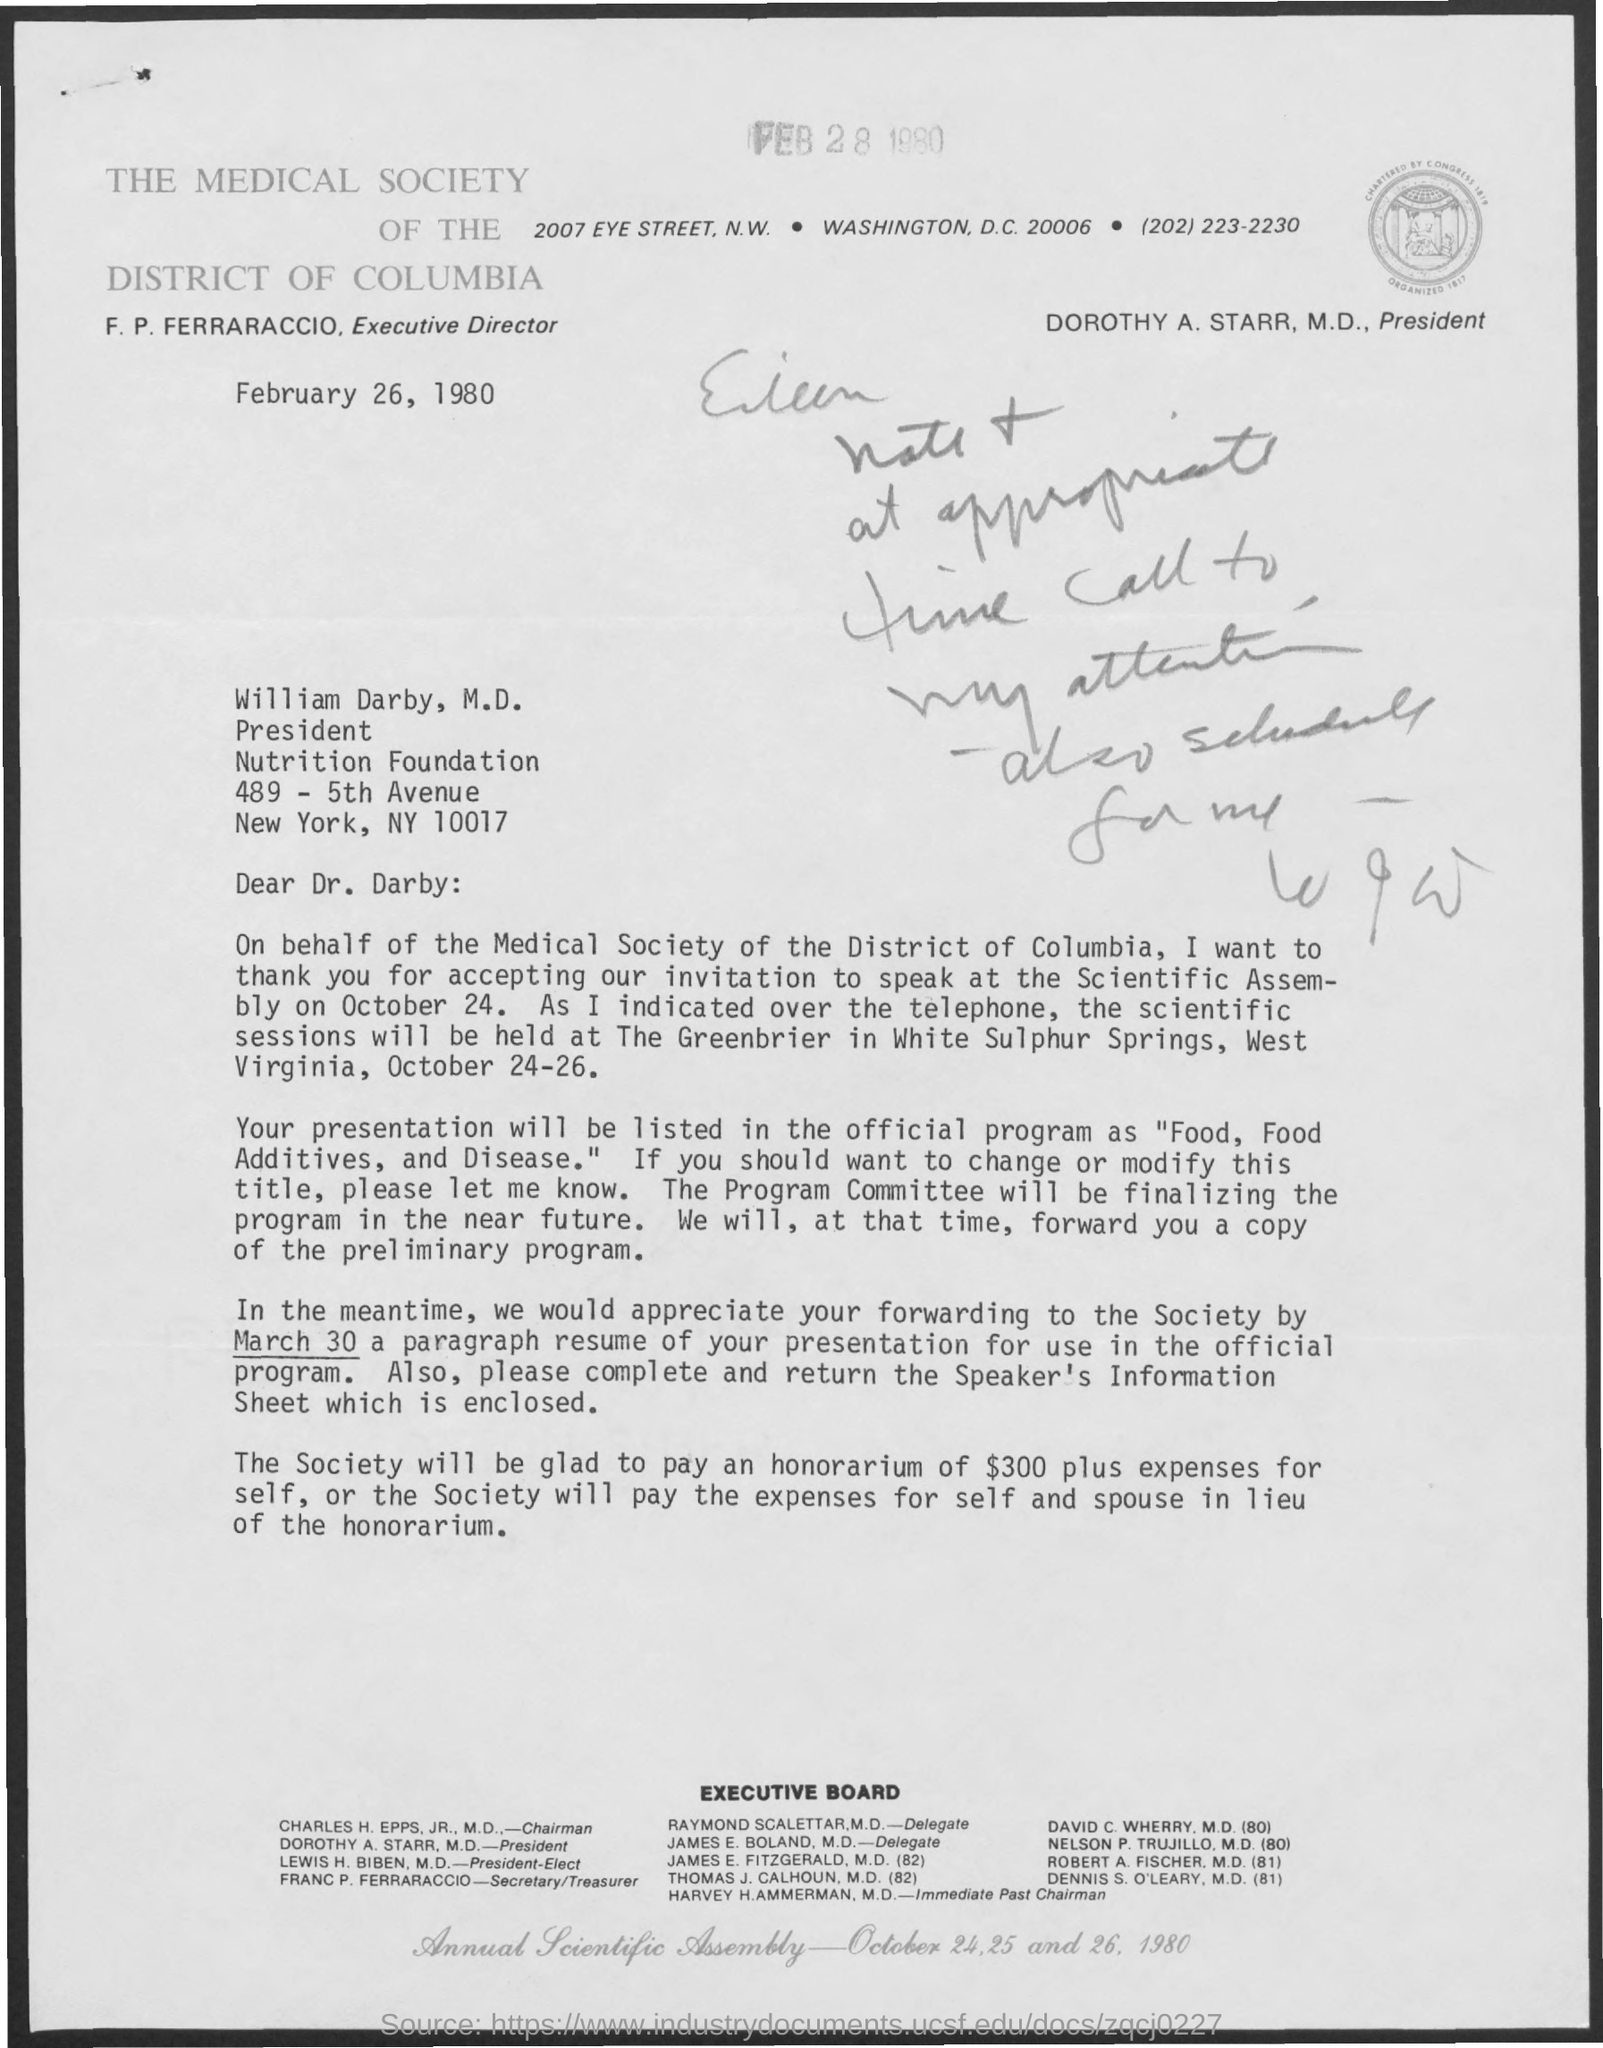Who is the Executive Director of THE MEDICAL SOCIETY OF THE DISTRICT OF COLUMBIA?
Your response must be concise. F. P. FERRARACCIO. By when should a paragraph resume of presentation for use in the official program be forwarded?
Ensure brevity in your answer.  March 30. When is the document dated?
Ensure brevity in your answer.  February 26, 1980. What is the amount of honorarium?
Offer a very short reply. $300. 